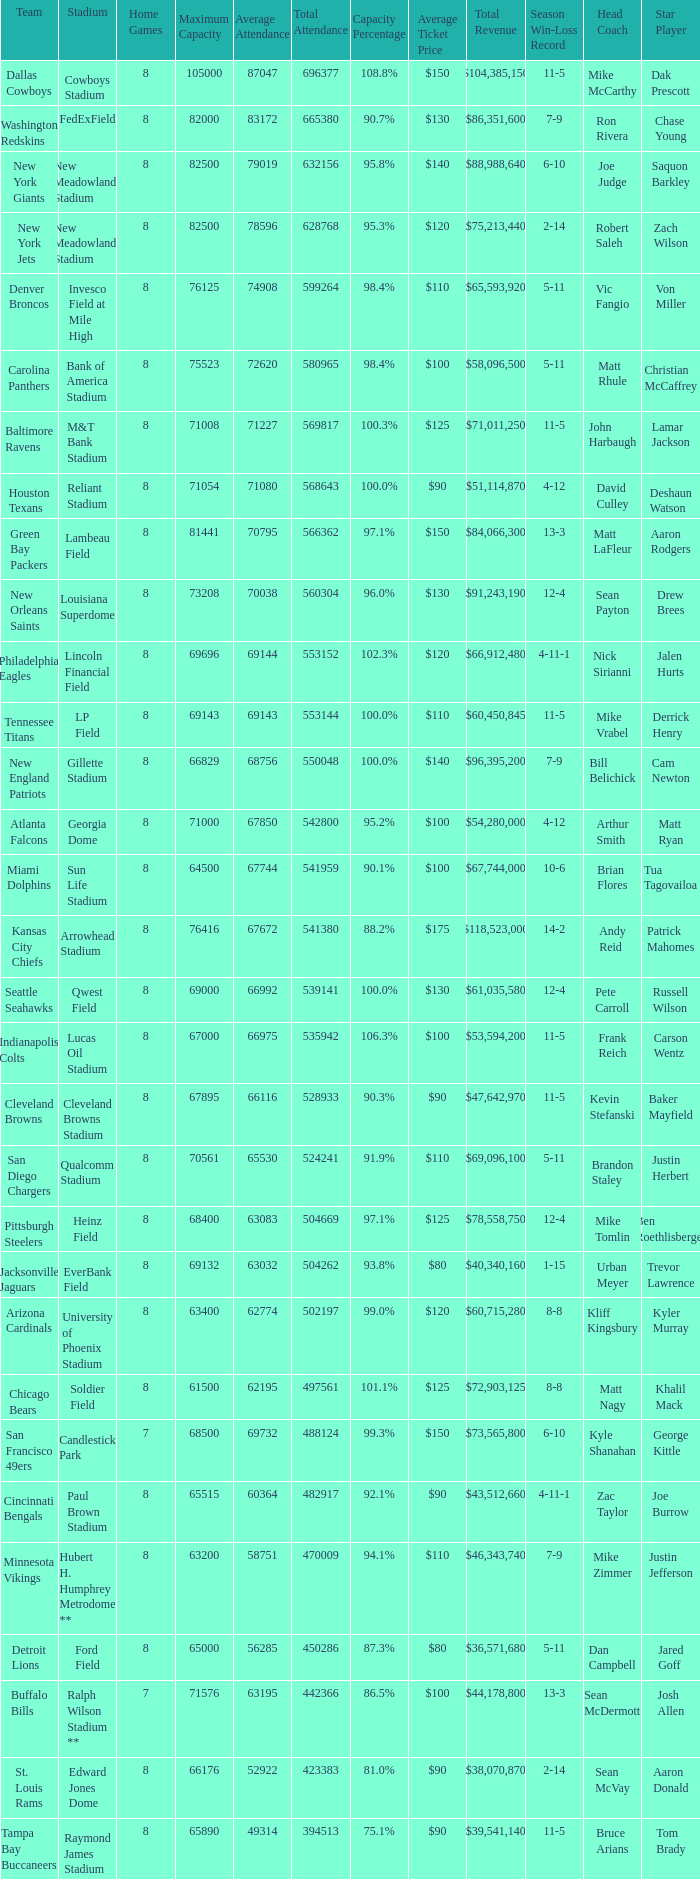How many teams had a 99.3% capacity rating? 1.0. 